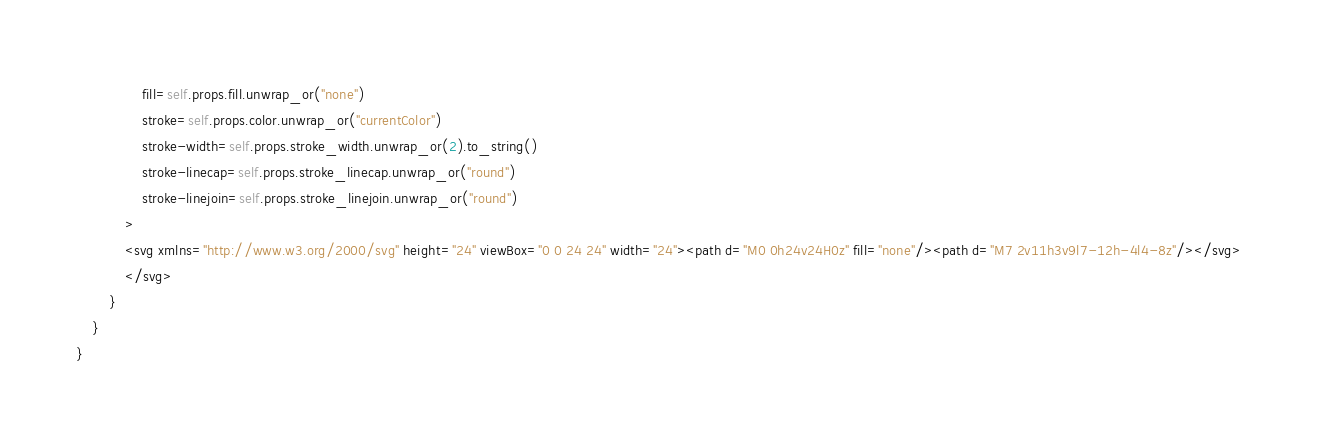<code> <loc_0><loc_0><loc_500><loc_500><_Rust_>                fill=self.props.fill.unwrap_or("none")
                stroke=self.props.color.unwrap_or("currentColor")
                stroke-width=self.props.stroke_width.unwrap_or(2).to_string()
                stroke-linecap=self.props.stroke_linecap.unwrap_or("round")
                stroke-linejoin=self.props.stroke_linejoin.unwrap_or("round")
            >
            <svg xmlns="http://www.w3.org/2000/svg" height="24" viewBox="0 0 24 24" width="24"><path d="M0 0h24v24H0z" fill="none"/><path d="M7 2v11h3v9l7-12h-4l4-8z"/></svg>
            </svg>
        }
    }
}


</code> 